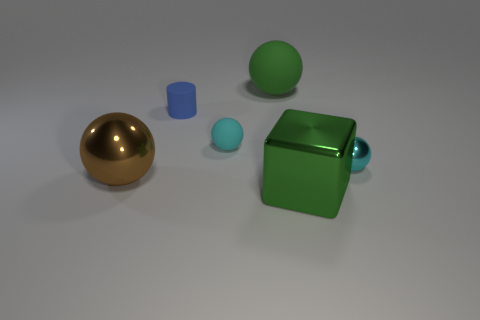Subtract all big rubber balls. How many balls are left? 3 Subtract all blue blocks. How many cyan balls are left? 2 Add 2 small green rubber things. How many objects exist? 8 Subtract all brown spheres. How many spheres are left? 3 Subtract 2 spheres. How many spheres are left? 2 Subtract all spheres. How many objects are left? 2 Subtract all small metal objects. Subtract all large green rubber objects. How many objects are left? 4 Add 3 rubber cylinders. How many rubber cylinders are left? 4 Add 5 big green metallic cubes. How many big green metallic cubes exist? 6 Subtract 0 brown blocks. How many objects are left? 6 